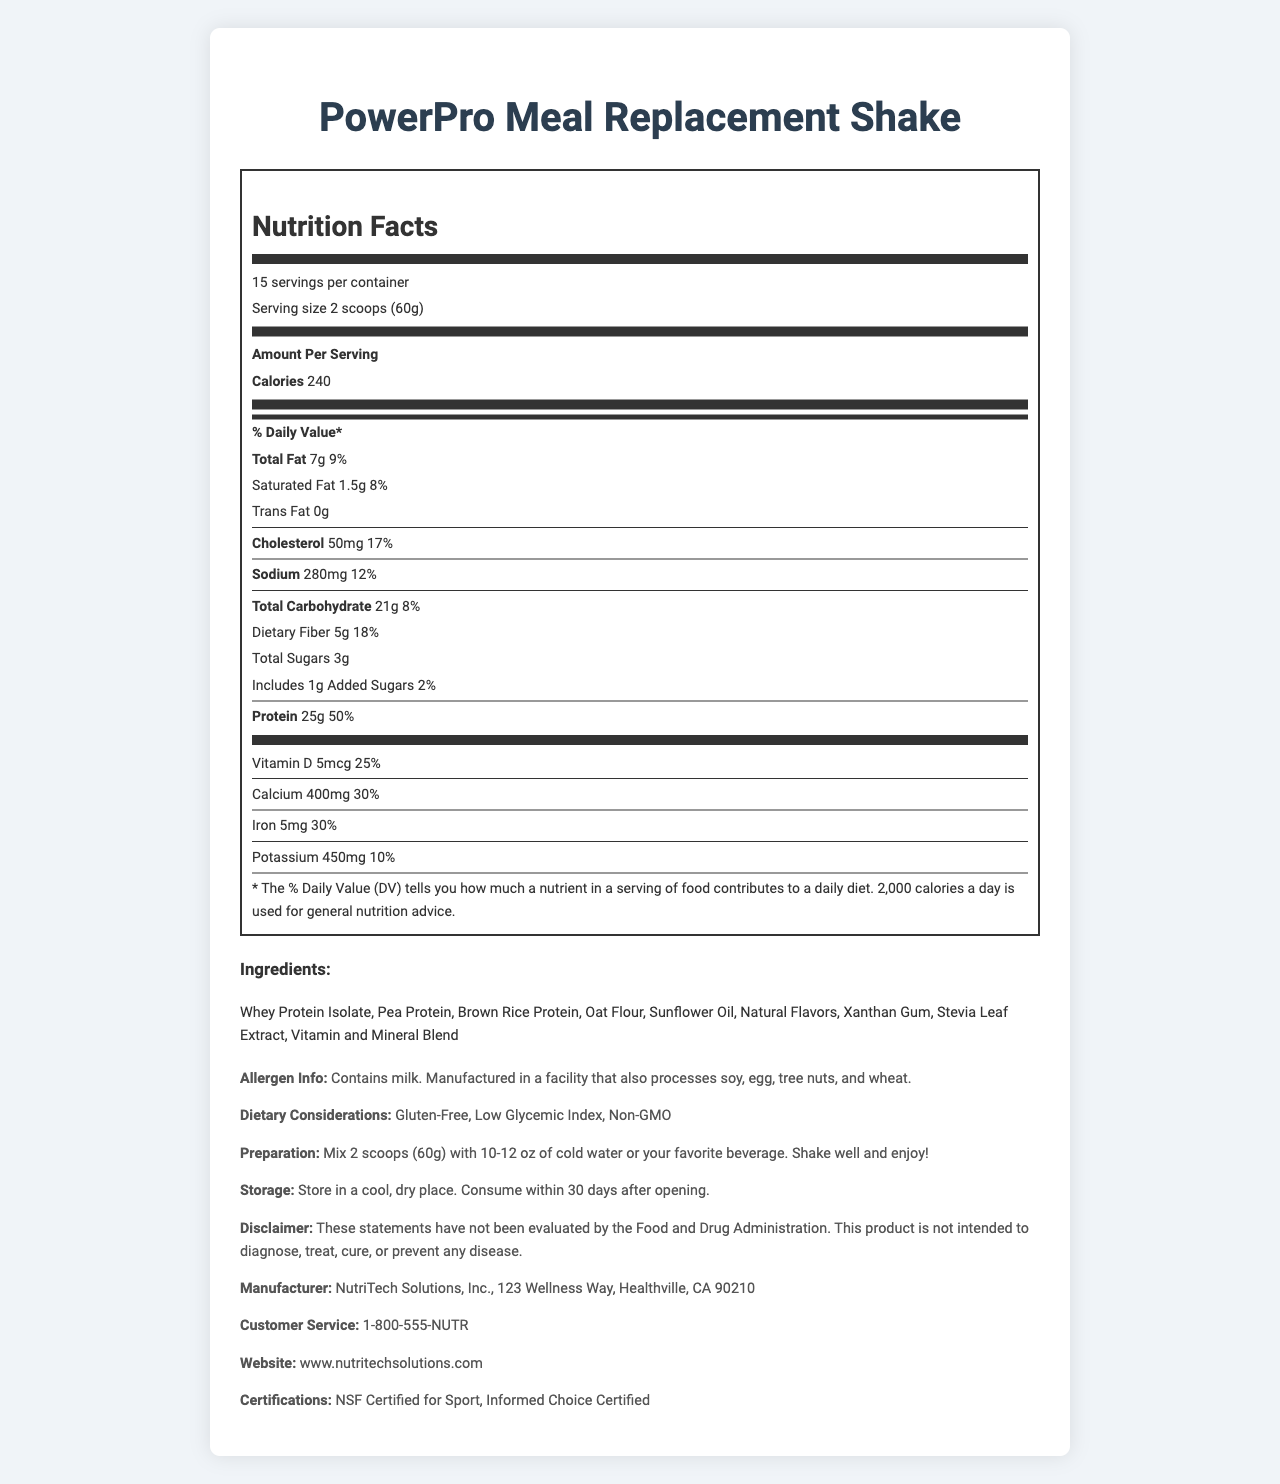what is the serving size of the PowerPro Meal Replacement Shake? The serving size is stated at the beginning under the "Servings Per Container" section.
Answer: 2 scoops (60g) How many servings are in one container of the PowerPro Meal Replacement Shake? This information is listed under "servings per container".
Answer: 15 How many grams of protein are in one serving of PowerPro Meal Replacement Shake? The protein content per serving is listed under the "Protein" section.
Answer: 25g What is the total fat content in one serving? The total fat amount is mentioned in the "Total Fat" section.
Answer: 7g What are the instructions for preparing the PowerPro Meal Replacement Shake? This information is found under the "Preparation Instructions" section.
Answer: Mix 2 scoops (60g) with 10-12 oz of cold water or your favorite beverage. Shake well and enjoy! How many calories does one serving of the PowerPro Meal Replacement Shake contain? The calorie content per serving is listed in the "Amount Per Serving" section.
Answer: 240 How much cholesterol is in one serving? The cholesterol amount is mentioned under the "Cholesterol" section.
Answer: 50mg Which of the following vitamins are present in the PowerPro Meal Replacement Shake? A. Vitamin A B. Vitamin B12 C. Vitamin D D. All of the above Vitamin A, Vitamin B12, and Vitamin D are all listed under the vitamin content sections.
Answer: D True or False: The PowerPro Meal Replacement Shake is gluten-free. This is stipulated in the "Dietary Considerations" section.
Answer: True Which nutrient has the highest daily value percentage in one serving of the shake? A. Calcium B. Iron C. Vitamin C D. Protein Protein has a daily value percentage of 50%, which is higher than the others listed.
Answer: D Does the PowerPro Meal Replacement Shake contain any trans fat? The trans fat content is listed as 0g.
Answer: No Describe the main purpose of the document. The document includes a nutrition facts label detailing amounts and daily value percentages for various nutrients, ingredients used, dietary considerations, as well as how to prepare and store the product, and information on the producer.
Answer: The primary purpose of this document is to provide detailed nutritional information, ingredient list, allergen information, preparation and storage instructions, manufacturing details, and certifications for the PowerPro Meal Replacement Shake. Does the PowerPro Meal Replacement Shake contain any allergens? It contains milk and is manufactured in a facility that also processes soy, egg, tree nuts, and wheat.
Answer: Yes Who manufactures the PowerPro Meal Replacement Shake? This information is found under the "Manufacturer" section.
Answer: NutriTech Solutions, Inc. What is the address of the manufacturer? The manufacturer's address is mentioned in the "Manufacturer" section.
Answer: 123 Wellness Way, Healthville, CA 90210 Can we determine if the shake is certified organic based on the document? The document does not provide any information regarding organic certification.
Answer: Cannot be determined 